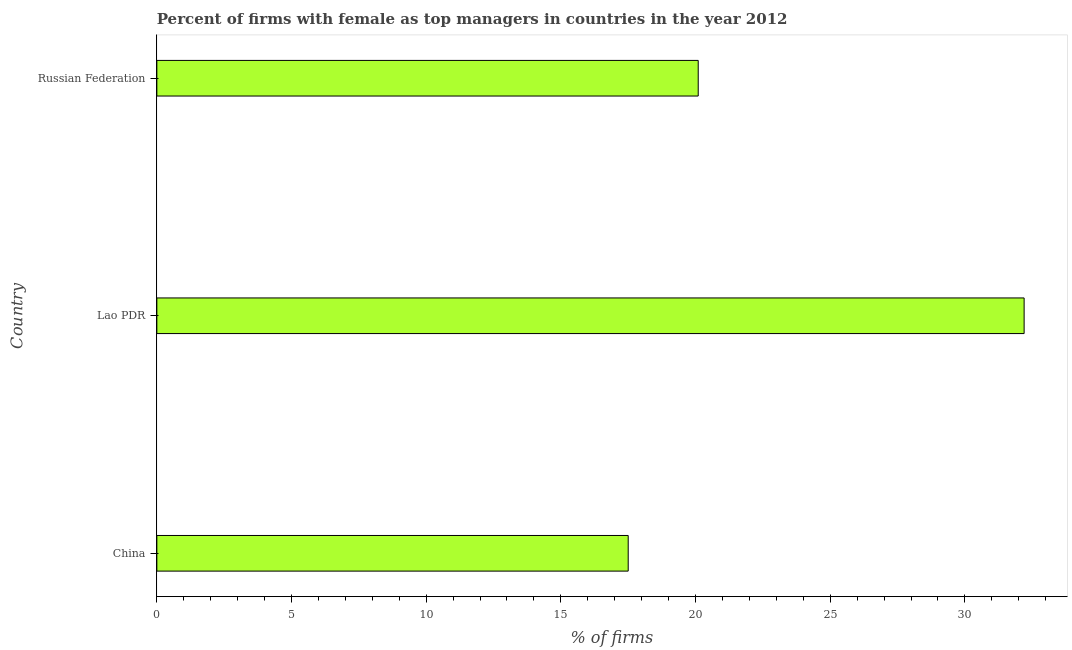Does the graph contain any zero values?
Ensure brevity in your answer.  No. Does the graph contain grids?
Your answer should be compact. No. What is the title of the graph?
Your answer should be very brief. Percent of firms with female as top managers in countries in the year 2012. What is the label or title of the X-axis?
Make the answer very short. % of firms. What is the label or title of the Y-axis?
Keep it short and to the point. Country. What is the percentage of firms with female as top manager in China?
Keep it short and to the point. 17.5. Across all countries, what is the maximum percentage of firms with female as top manager?
Your response must be concise. 32.2. Across all countries, what is the minimum percentage of firms with female as top manager?
Provide a short and direct response. 17.5. In which country was the percentage of firms with female as top manager maximum?
Make the answer very short. Lao PDR. In which country was the percentage of firms with female as top manager minimum?
Offer a terse response. China. What is the sum of the percentage of firms with female as top manager?
Give a very brief answer. 69.8. What is the difference between the percentage of firms with female as top manager in China and Lao PDR?
Provide a succinct answer. -14.7. What is the average percentage of firms with female as top manager per country?
Your response must be concise. 23.27. What is the median percentage of firms with female as top manager?
Provide a short and direct response. 20.1. What is the ratio of the percentage of firms with female as top manager in China to that in Lao PDR?
Your response must be concise. 0.54. Is the percentage of firms with female as top manager in China less than that in Lao PDR?
Provide a succinct answer. Yes. Is the difference between the percentage of firms with female as top manager in China and Lao PDR greater than the difference between any two countries?
Ensure brevity in your answer.  Yes. What is the difference between the highest and the second highest percentage of firms with female as top manager?
Your response must be concise. 12.1. What is the difference between the highest and the lowest percentage of firms with female as top manager?
Your response must be concise. 14.7. In how many countries, is the percentage of firms with female as top manager greater than the average percentage of firms with female as top manager taken over all countries?
Make the answer very short. 1. Are all the bars in the graph horizontal?
Offer a terse response. Yes. What is the difference between two consecutive major ticks on the X-axis?
Offer a very short reply. 5. Are the values on the major ticks of X-axis written in scientific E-notation?
Offer a very short reply. No. What is the % of firms of Lao PDR?
Offer a terse response. 32.2. What is the % of firms in Russian Federation?
Your answer should be very brief. 20.1. What is the difference between the % of firms in China and Lao PDR?
Offer a very short reply. -14.7. What is the difference between the % of firms in China and Russian Federation?
Offer a very short reply. -2.6. What is the difference between the % of firms in Lao PDR and Russian Federation?
Your answer should be compact. 12.1. What is the ratio of the % of firms in China to that in Lao PDR?
Offer a terse response. 0.54. What is the ratio of the % of firms in China to that in Russian Federation?
Offer a terse response. 0.87. What is the ratio of the % of firms in Lao PDR to that in Russian Federation?
Ensure brevity in your answer.  1.6. 